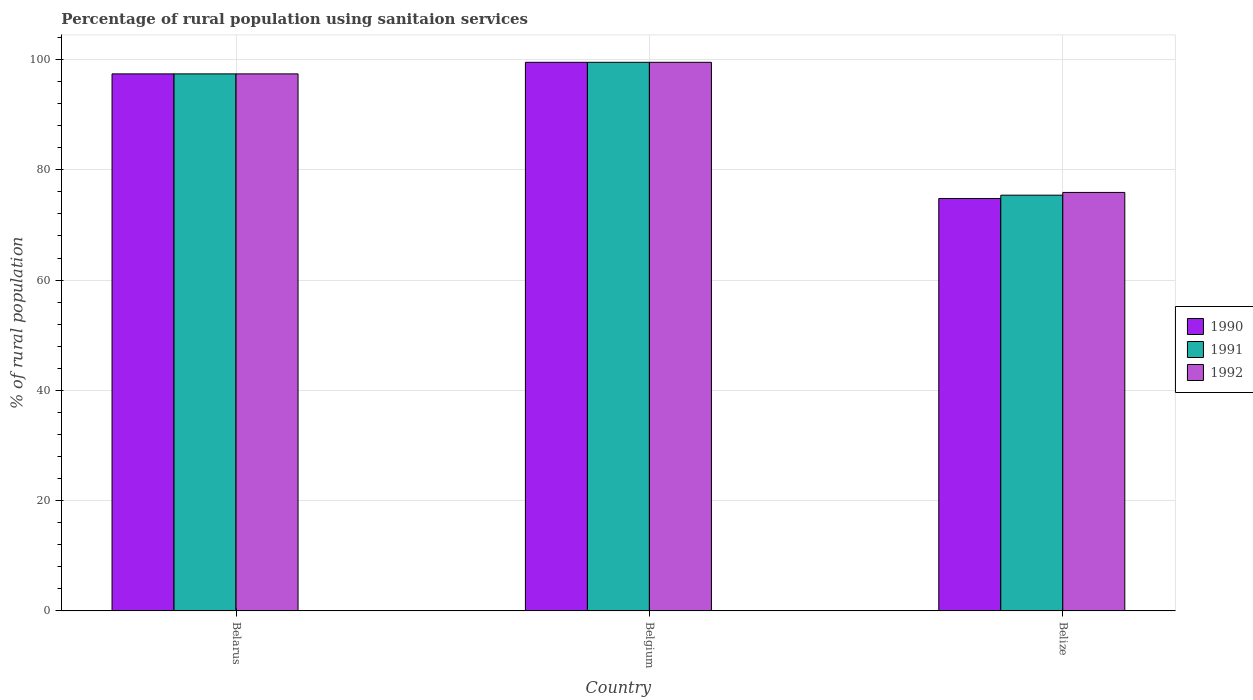How many bars are there on the 3rd tick from the right?
Your answer should be compact. 3. What is the label of the 3rd group of bars from the left?
Make the answer very short. Belize. In how many cases, is the number of bars for a given country not equal to the number of legend labels?
Provide a succinct answer. 0. What is the percentage of rural population using sanitaion services in 1991 in Belgium?
Provide a short and direct response. 99.5. Across all countries, what is the maximum percentage of rural population using sanitaion services in 1990?
Provide a short and direct response. 99.5. Across all countries, what is the minimum percentage of rural population using sanitaion services in 1990?
Keep it short and to the point. 74.8. In which country was the percentage of rural population using sanitaion services in 1991 minimum?
Your answer should be compact. Belize. What is the total percentage of rural population using sanitaion services in 1991 in the graph?
Your answer should be very brief. 272.3. What is the difference between the percentage of rural population using sanitaion services in 1990 in Belarus and that in Belgium?
Ensure brevity in your answer.  -2.1. What is the difference between the percentage of rural population using sanitaion services in 1992 in Belize and the percentage of rural population using sanitaion services in 1991 in Belgium?
Make the answer very short. -23.6. What is the average percentage of rural population using sanitaion services in 1991 per country?
Provide a short and direct response. 90.77. What is the difference between the percentage of rural population using sanitaion services of/in 1992 and percentage of rural population using sanitaion services of/in 1991 in Belgium?
Your response must be concise. 0. What is the ratio of the percentage of rural population using sanitaion services in 1992 in Belgium to that in Belize?
Make the answer very short. 1.31. Is the percentage of rural population using sanitaion services in 1991 in Belgium less than that in Belize?
Your answer should be very brief. No. Is the difference between the percentage of rural population using sanitaion services in 1992 in Belarus and Belgium greater than the difference between the percentage of rural population using sanitaion services in 1991 in Belarus and Belgium?
Your answer should be very brief. No. What is the difference between the highest and the second highest percentage of rural population using sanitaion services in 1990?
Offer a terse response. 22.6. What is the difference between the highest and the lowest percentage of rural population using sanitaion services in 1992?
Provide a succinct answer. 23.6. In how many countries, is the percentage of rural population using sanitaion services in 1990 greater than the average percentage of rural population using sanitaion services in 1990 taken over all countries?
Offer a very short reply. 2. What does the 2nd bar from the right in Belarus represents?
Provide a short and direct response. 1991. How many countries are there in the graph?
Offer a very short reply. 3. Does the graph contain any zero values?
Provide a succinct answer. No. Does the graph contain grids?
Offer a terse response. Yes. Where does the legend appear in the graph?
Make the answer very short. Center right. What is the title of the graph?
Your response must be concise. Percentage of rural population using sanitaion services. What is the label or title of the Y-axis?
Your answer should be very brief. % of rural population. What is the % of rural population in 1990 in Belarus?
Your response must be concise. 97.4. What is the % of rural population in 1991 in Belarus?
Provide a short and direct response. 97.4. What is the % of rural population of 1992 in Belarus?
Offer a terse response. 97.4. What is the % of rural population in 1990 in Belgium?
Offer a terse response. 99.5. What is the % of rural population in 1991 in Belgium?
Offer a very short reply. 99.5. What is the % of rural population of 1992 in Belgium?
Your answer should be compact. 99.5. What is the % of rural population of 1990 in Belize?
Your answer should be very brief. 74.8. What is the % of rural population of 1991 in Belize?
Offer a very short reply. 75.4. What is the % of rural population of 1992 in Belize?
Give a very brief answer. 75.9. Across all countries, what is the maximum % of rural population in 1990?
Provide a short and direct response. 99.5. Across all countries, what is the maximum % of rural population of 1991?
Your response must be concise. 99.5. Across all countries, what is the maximum % of rural population of 1992?
Give a very brief answer. 99.5. Across all countries, what is the minimum % of rural population of 1990?
Give a very brief answer. 74.8. Across all countries, what is the minimum % of rural population in 1991?
Ensure brevity in your answer.  75.4. Across all countries, what is the minimum % of rural population in 1992?
Ensure brevity in your answer.  75.9. What is the total % of rural population of 1990 in the graph?
Offer a terse response. 271.7. What is the total % of rural population in 1991 in the graph?
Your answer should be compact. 272.3. What is the total % of rural population in 1992 in the graph?
Ensure brevity in your answer.  272.8. What is the difference between the % of rural population of 1990 in Belarus and that in Belgium?
Give a very brief answer. -2.1. What is the difference between the % of rural population in 1991 in Belarus and that in Belgium?
Offer a terse response. -2.1. What is the difference between the % of rural population of 1990 in Belarus and that in Belize?
Keep it short and to the point. 22.6. What is the difference between the % of rural population in 1992 in Belarus and that in Belize?
Your answer should be very brief. 21.5. What is the difference between the % of rural population in 1990 in Belgium and that in Belize?
Give a very brief answer. 24.7. What is the difference between the % of rural population of 1991 in Belgium and that in Belize?
Your answer should be very brief. 24.1. What is the difference between the % of rural population of 1992 in Belgium and that in Belize?
Offer a very short reply. 23.6. What is the difference between the % of rural population in 1990 in Belarus and the % of rural population in 1991 in Belgium?
Your answer should be compact. -2.1. What is the difference between the % of rural population of 1990 in Belarus and the % of rural population of 1991 in Belize?
Your answer should be compact. 22. What is the difference between the % of rural population of 1990 in Belgium and the % of rural population of 1991 in Belize?
Your response must be concise. 24.1. What is the difference between the % of rural population in 1990 in Belgium and the % of rural population in 1992 in Belize?
Provide a succinct answer. 23.6. What is the difference between the % of rural population of 1991 in Belgium and the % of rural population of 1992 in Belize?
Offer a terse response. 23.6. What is the average % of rural population in 1990 per country?
Offer a terse response. 90.57. What is the average % of rural population of 1991 per country?
Ensure brevity in your answer.  90.77. What is the average % of rural population in 1992 per country?
Make the answer very short. 90.93. What is the difference between the % of rural population in 1990 and % of rural population in 1992 in Belarus?
Keep it short and to the point. 0. What is the difference between the % of rural population of 1990 and % of rural population of 1992 in Belgium?
Offer a terse response. 0. What is the difference between the % of rural population of 1991 and % of rural population of 1992 in Belgium?
Provide a short and direct response. 0. What is the ratio of the % of rural population of 1990 in Belarus to that in Belgium?
Make the answer very short. 0.98. What is the ratio of the % of rural population of 1991 in Belarus to that in Belgium?
Give a very brief answer. 0.98. What is the ratio of the % of rural population in 1992 in Belarus to that in Belgium?
Your answer should be very brief. 0.98. What is the ratio of the % of rural population in 1990 in Belarus to that in Belize?
Provide a succinct answer. 1.3. What is the ratio of the % of rural population of 1991 in Belarus to that in Belize?
Your response must be concise. 1.29. What is the ratio of the % of rural population of 1992 in Belarus to that in Belize?
Your answer should be compact. 1.28. What is the ratio of the % of rural population of 1990 in Belgium to that in Belize?
Make the answer very short. 1.33. What is the ratio of the % of rural population of 1991 in Belgium to that in Belize?
Provide a succinct answer. 1.32. What is the ratio of the % of rural population in 1992 in Belgium to that in Belize?
Offer a terse response. 1.31. What is the difference between the highest and the second highest % of rural population in 1990?
Provide a succinct answer. 2.1. What is the difference between the highest and the second highest % of rural population of 1991?
Ensure brevity in your answer.  2.1. What is the difference between the highest and the lowest % of rural population in 1990?
Your answer should be compact. 24.7. What is the difference between the highest and the lowest % of rural population of 1991?
Keep it short and to the point. 24.1. What is the difference between the highest and the lowest % of rural population in 1992?
Give a very brief answer. 23.6. 